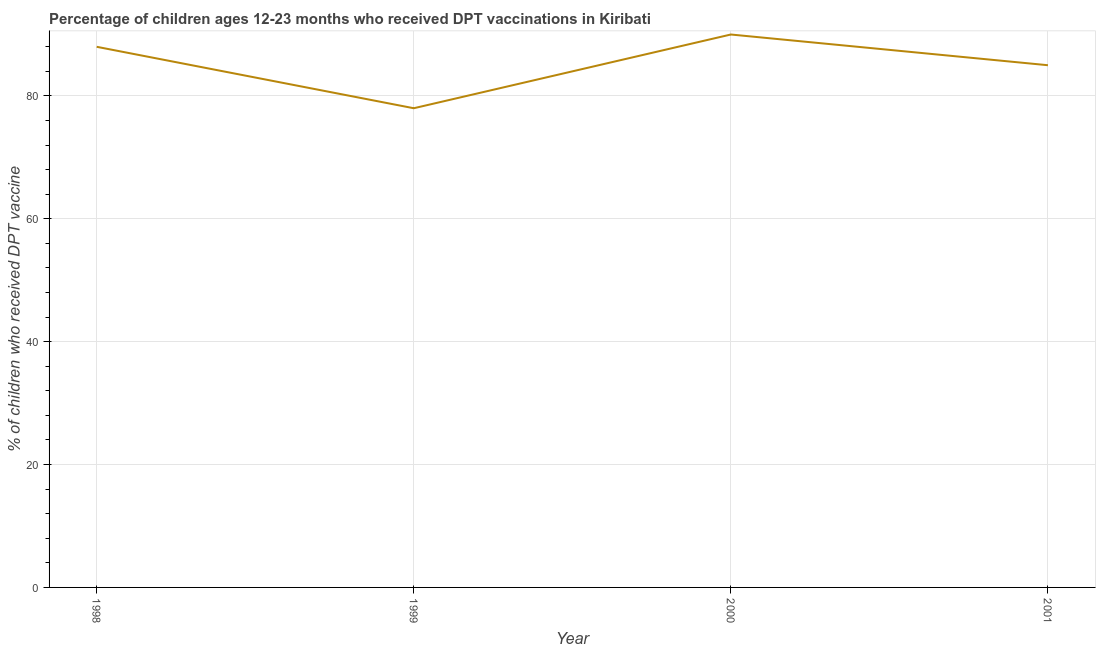What is the percentage of children who received dpt vaccine in 1999?
Ensure brevity in your answer.  78. Across all years, what is the maximum percentage of children who received dpt vaccine?
Your answer should be very brief. 90. Across all years, what is the minimum percentage of children who received dpt vaccine?
Give a very brief answer. 78. In which year was the percentage of children who received dpt vaccine maximum?
Make the answer very short. 2000. What is the sum of the percentage of children who received dpt vaccine?
Ensure brevity in your answer.  341. What is the difference between the percentage of children who received dpt vaccine in 2000 and 2001?
Your response must be concise. 5. What is the average percentage of children who received dpt vaccine per year?
Offer a very short reply. 85.25. What is the median percentage of children who received dpt vaccine?
Provide a short and direct response. 86.5. In how many years, is the percentage of children who received dpt vaccine greater than 60 %?
Provide a succinct answer. 4. What is the ratio of the percentage of children who received dpt vaccine in 1998 to that in 2001?
Provide a succinct answer. 1.04. Is the sum of the percentage of children who received dpt vaccine in 1998 and 1999 greater than the maximum percentage of children who received dpt vaccine across all years?
Ensure brevity in your answer.  Yes. What is the difference between the highest and the lowest percentage of children who received dpt vaccine?
Ensure brevity in your answer.  12. In how many years, is the percentage of children who received dpt vaccine greater than the average percentage of children who received dpt vaccine taken over all years?
Your answer should be very brief. 2. How many lines are there?
Offer a terse response. 1. What is the difference between two consecutive major ticks on the Y-axis?
Offer a terse response. 20. Are the values on the major ticks of Y-axis written in scientific E-notation?
Ensure brevity in your answer.  No. Does the graph contain any zero values?
Provide a succinct answer. No. What is the title of the graph?
Your answer should be compact. Percentage of children ages 12-23 months who received DPT vaccinations in Kiribati. What is the label or title of the X-axis?
Provide a short and direct response. Year. What is the label or title of the Y-axis?
Provide a succinct answer. % of children who received DPT vaccine. What is the % of children who received DPT vaccine of 2001?
Offer a very short reply. 85. What is the difference between the % of children who received DPT vaccine in 1998 and 1999?
Keep it short and to the point. 10. What is the difference between the % of children who received DPT vaccine in 1998 and 2000?
Make the answer very short. -2. What is the ratio of the % of children who received DPT vaccine in 1998 to that in 1999?
Make the answer very short. 1.13. What is the ratio of the % of children who received DPT vaccine in 1998 to that in 2001?
Ensure brevity in your answer.  1.03. What is the ratio of the % of children who received DPT vaccine in 1999 to that in 2000?
Provide a short and direct response. 0.87. What is the ratio of the % of children who received DPT vaccine in 1999 to that in 2001?
Provide a succinct answer. 0.92. What is the ratio of the % of children who received DPT vaccine in 2000 to that in 2001?
Offer a terse response. 1.06. 